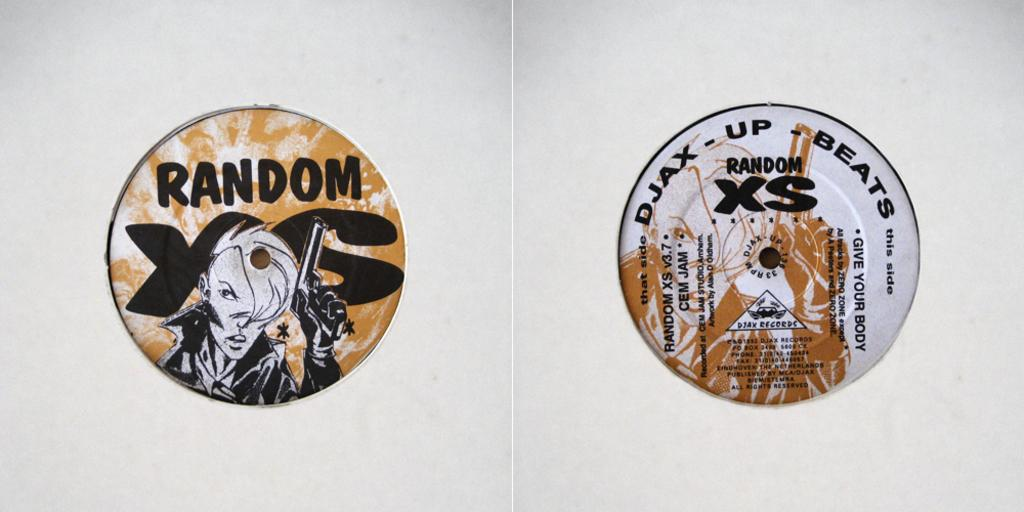<image>
Share a concise interpretation of the image provided. Disc that says the word RANDOM next to one that says RANDOM XS on it. 